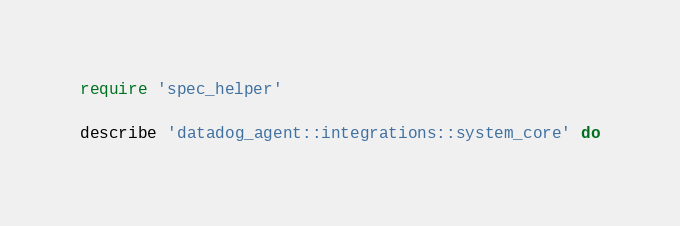Convert code to text. <code><loc_0><loc_0><loc_500><loc_500><_Ruby_>require 'spec_helper'

describe 'datadog_agent::integrations::system_core' do</code> 